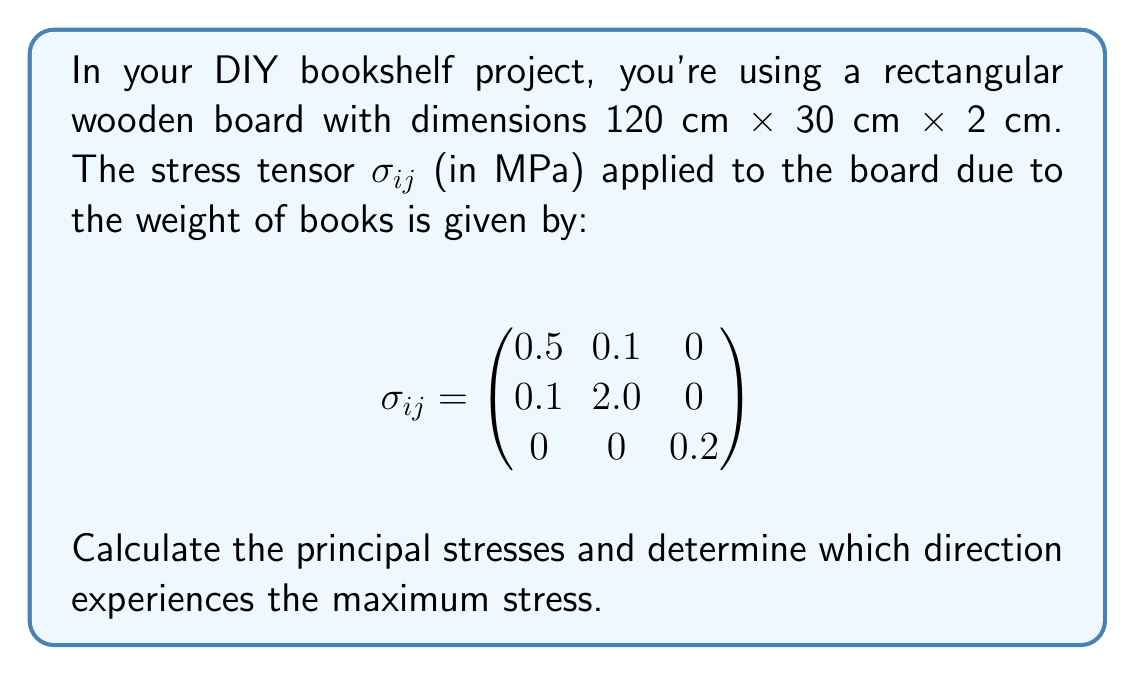What is the answer to this math problem? Let's approach this step-by-step:

1) To find the principal stresses, we need to solve the characteristic equation:
   $$\det(\sigma_{ij} - \lambda I) = 0$$

2) Expanding this determinant:
   $$\begin{vmatrix}
   0.5 - \lambda & 0.1 & 0 \\
   0.1 & 2.0 - \lambda & 0 \\
   0 & 0 & 0.2 - \lambda
   \end{vmatrix} = 0$$

3) This gives us the cubic equation:
   $$(0.5 - \lambda)(2.0 - \lambda)(0.2 - \lambda) - 0.1^2(0.2 - \lambda) = 0$$

4) Simplifying:
   $$\lambda^3 - 2.7\lambda^2 + 1.99\lambda - 0.199 = 0$$

5) Using a cubic equation solver (which you might imagine as a DIY calculator project), we get the roots:
   $$\lambda_1 \approx 2.0398, \lambda_2 \approx 0.4602, \lambda_3 = 0.2$$

6) These are the principal stresses. The maximum stress is $\lambda_1 \approx 2.0398$ MPa.

7) To find the direction of maximum stress, we need to find the eigenvector corresponding to $\lambda_1$. This involves solving:
   $$(\sigma_{ij} - \lambda_1 I)\vec{v} = 0$$

8) After calculations, we find that the eigenvector is approximately:
   $$\vec{v} \approx (0.0491, 0.9988, 0)$$

9) This vector is nearly aligned with the y-axis of our coordinate system, which corresponds to the 30 cm width of the board.
Answer: Principal stresses: 2.0398 MPa, 0.4602 MPa, 0.2 MPa. Maximum stress: 2.0398 MPa, direction: approximately along the board's width. 